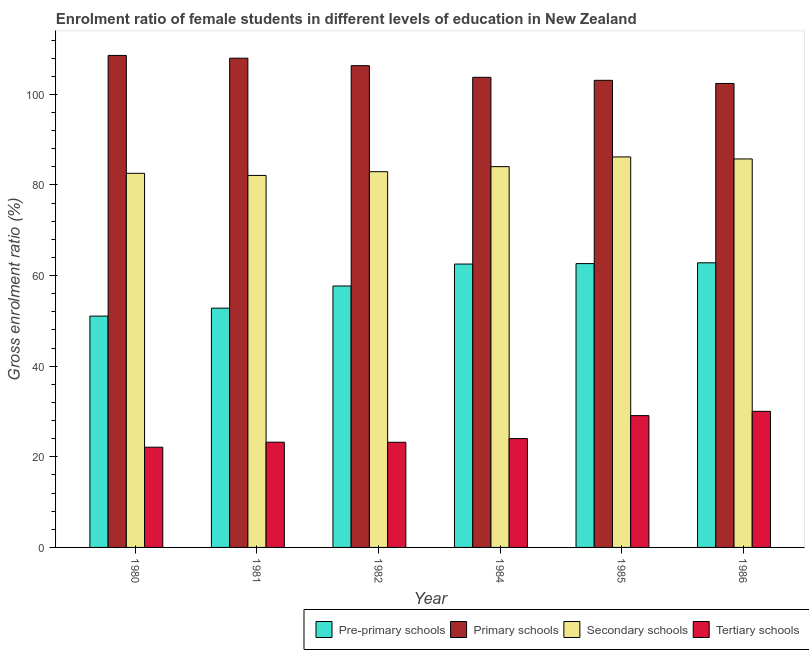How many different coloured bars are there?
Keep it short and to the point. 4. How many groups of bars are there?
Your answer should be compact. 6. Are the number of bars on each tick of the X-axis equal?
Give a very brief answer. Yes. How many bars are there on the 1st tick from the right?
Ensure brevity in your answer.  4. In how many cases, is the number of bars for a given year not equal to the number of legend labels?
Offer a very short reply. 0. What is the gross enrolment ratio(male) in pre-primary schools in 1980?
Your response must be concise. 51.06. Across all years, what is the maximum gross enrolment ratio(male) in primary schools?
Ensure brevity in your answer.  108.6. Across all years, what is the minimum gross enrolment ratio(male) in primary schools?
Your answer should be very brief. 102.41. In which year was the gross enrolment ratio(male) in primary schools maximum?
Your answer should be compact. 1980. In which year was the gross enrolment ratio(male) in secondary schools minimum?
Ensure brevity in your answer.  1981. What is the total gross enrolment ratio(male) in primary schools in the graph?
Provide a succinct answer. 632.19. What is the difference between the gross enrolment ratio(male) in secondary schools in 1981 and that in 1985?
Give a very brief answer. -4.08. What is the difference between the gross enrolment ratio(male) in primary schools in 1984 and the gross enrolment ratio(male) in tertiary schools in 1980?
Your answer should be very brief. -4.83. What is the average gross enrolment ratio(male) in secondary schools per year?
Provide a short and direct response. 83.93. What is the ratio of the gross enrolment ratio(male) in pre-primary schools in 1980 to that in 1985?
Give a very brief answer. 0.82. Is the gross enrolment ratio(male) in pre-primary schools in 1984 less than that in 1985?
Offer a very short reply. Yes. What is the difference between the highest and the second highest gross enrolment ratio(male) in tertiary schools?
Offer a very short reply. 0.94. What is the difference between the highest and the lowest gross enrolment ratio(male) in pre-primary schools?
Your answer should be very brief. 11.76. Is the sum of the gross enrolment ratio(male) in secondary schools in 1982 and 1986 greater than the maximum gross enrolment ratio(male) in primary schools across all years?
Make the answer very short. Yes. What does the 4th bar from the left in 1986 represents?
Ensure brevity in your answer.  Tertiary schools. What does the 1st bar from the right in 1980 represents?
Provide a succinct answer. Tertiary schools. Is it the case that in every year, the sum of the gross enrolment ratio(male) in pre-primary schools and gross enrolment ratio(male) in primary schools is greater than the gross enrolment ratio(male) in secondary schools?
Make the answer very short. Yes. How many bars are there?
Ensure brevity in your answer.  24. Does the graph contain any zero values?
Your answer should be very brief. No. Does the graph contain grids?
Offer a terse response. No. What is the title of the graph?
Your answer should be very brief. Enrolment ratio of female students in different levels of education in New Zealand. Does "Tertiary schools" appear as one of the legend labels in the graph?
Offer a very short reply. Yes. What is the label or title of the X-axis?
Your answer should be very brief. Year. What is the label or title of the Y-axis?
Make the answer very short. Gross enrolment ratio (%). What is the Gross enrolment ratio (%) in Pre-primary schools in 1980?
Your response must be concise. 51.06. What is the Gross enrolment ratio (%) in Primary schools in 1980?
Provide a short and direct response. 108.6. What is the Gross enrolment ratio (%) of Secondary schools in 1980?
Give a very brief answer. 82.58. What is the Gross enrolment ratio (%) in Tertiary schools in 1980?
Your answer should be very brief. 22.12. What is the Gross enrolment ratio (%) in Pre-primary schools in 1981?
Your answer should be compact. 52.81. What is the Gross enrolment ratio (%) in Primary schools in 1981?
Provide a short and direct response. 107.99. What is the Gross enrolment ratio (%) in Secondary schools in 1981?
Keep it short and to the point. 82.11. What is the Gross enrolment ratio (%) in Tertiary schools in 1981?
Ensure brevity in your answer.  23.23. What is the Gross enrolment ratio (%) of Pre-primary schools in 1982?
Offer a very short reply. 57.7. What is the Gross enrolment ratio (%) of Primary schools in 1982?
Provide a short and direct response. 106.33. What is the Gross enrolment ratio (%) of Secondary schools in 1982?
Ensure brevity in your answer.  82.93. What is the Gross enrolment ratio (%) in Tertiary schools in 1982?
Provide a succinct answer. 23.21. What is the Gross enrolment ratio (%) of Pre-primary schools in 1984?
Give a very brief answer. 62.55. What is the Gross enrolment ratio (%) of Primary schools in 1984?
Your answer should be very brief. 103.76. What is the Gross enrolment ratio (%) of Secondary schools in 1984?
Keep it short and to the point. 84.05. What is the Gross enrolment ratio (%) in Tertiary schools in 1984?
Offer a very short reply. 24.03. What is the Gross enrolment ratio (%) in Pre-primary schools in 1985?
Provide a succinct answer. 62.65. What is the Gross enrolment ratio (%) of Primary schools in 1985?
Provide a succinct answer. 103.1. What is the Gross enrolment ratio (%) of Secondary schools in 1985?
Offer a very short reply. 86.19. What is the Gross enrolment ratio (%) in Tertiary schools in 1985?
Give a very brief answer. 29.1. What is the Gross enrolment ratio (%) in Pre-primary schools in 1986?
Give a very brief answer. 62.82. What is the Gross enrolment ratio (%) of Primary schools in 1986?
Your response must be concise. 102.41. What is the Gross enrolment ratio (%) of Secondary schools in 1986?
Keep it short and to the point. 85.75. What is the Gross enrolment ratio (%) in Tertiary schools in 1986?
Your response must be concise. 30.04. Across all years, what is the maximum Gross enrolment ratio (%) of Pre-primary schools?
Your answer should be compact. 62.82. Across all years, what is the maximum Gross enrolment ratio (%) in Primary schools?
Give a very brief answer. 108.6. Across all years, what is the maximum Gross enrolment ratio (%) in Secondary schools?
Your response must be concise. 86.19. Across all years, what is the maximum Gross enrolment ratio (%) in Tertiary schools?
Your answer should be compact. 30.04. Across all years, what is the minimum Gross enrolment ratio (%) in Pre-primary schools?
Provide a succinct answer. 51.06. Across all years, what is the minimum Gross enrolment ratio (%) in Primary schools?
Ensure brevity in your answer.  102.41. Across all years, what is the minimum Gross enrolment ratio (%) in Secondary schools?
Provide a short and direct response. 82.11. Across all years, what is the minimum Gross enrolment ratio (%) in Tertiary schools?
Keep it short and to the point. 22.12. What is the total Gross enrolment ratio (%) of Pre-primary schools in the graph?
Provide a succinct answer. 349.59. What is the total Gross enrolment ratio (%) in Primary schools in the graph?
Your answer should be very brief. 632.19. What is the total Gross enrolment ratio (%) of Secondary schools in the graph?
Make the answer very short. 503.6. What is the total Gross enrolment ratio (%) in Tertiary schools in the graph?
Keep it short and to the point. 151.72. What is the difference between the Gross enrolment ratio (%) in Pre-primary schools in 1980 and that in 1981?
Offer a very short reply. -1.76. What is the difference between the Gross enrolment ratio (%) of Primary schools in 1980 and that in 1981?
Provide a succinct answer. 0.61. What is the difference between the Gross enrolment ratio (%) of Secondary schools in 1980 and that in 1981?
Your answer should be compact. 0.47. What is the difference between the Gross enrolment ratio (%) of Tertiary schools in 1980 and that in 1981?
Give a very brief answer. -1.11. What is the difference between the Gross enrolment ratio (%) of Pre-primary schools in 1980 and that in 1982?
Offer a very short reply. -6.65. What is the difference between the Gross enrolment ratio (%) in Primary schools in 1980 and that in 1982?
Keep it short and to the point. 2.26. What is the difference between the Gross enrolment ratio (%) in Secondary schools in 1980 and that in 1982?
Offer a terse response. -0.36. What is the difference between the Gross enrolment ratio (%) in Tertiary schools in 1980 and that in 1982?
Give a very brief answer. -1.09. What is the difference between the Gross enrolment ratio (%) in Pre-primary schools in 1980 and that in 1984?
Provide a short and direct response. -11.49. What is the difference between the Gross enrolment ratio (%) of Primary schools in 1980 and that in 1984?
Give a very brief answer. 4.83. What is the difference between the Gross enrolment ratio (%) in Secondary schools in 1980 and that in 1984?
Your response must be concise. -1.47. What is the difference between the Gross enrolment ratio (%) in Tertiary schools in 1980 and that in 1984?
Ensure brevity in your answer.  -1.91. What is the difference between the Gross enrolment ratio (%) in Pre-primary schools in 1980 and that in 1985?
Provide a short and direct response. -11.59. What is the difference between the Gross enrolment ratio (%) in Primary schools in 1980 and that in 1985?
Your answer should be compact. 5.5. What is the difference between the Gross enrolment ratio (%) in Secondary schools in 1980 and that in 1985?
Offer a terse response. -3.62. What is the difference between the Gross enrolment ratio (%) in Tertiary schools in 1980 and that in 1985?
Provide a short and direct response. -6.98. What is the difference between the Gross enrolment ratio (%) in Pre-primary schools in 1980 and that in 1986?
Provide a short and direct response. -11.76. What is the difference between the Gross enrolment ratio (%) in Primary schools in 1980 and that in 1986?
Keep it short and to the point. 6.19. What is the difference between the Gross enrolment ratio (%) of Secondary schools in 1980 and that in 1986?
Your answer should be very brief. -3.17. What is the difference between the Gross enrolment ratio (%) in Tertiary schools in 1980 and that in 1986?
Offer a terse response. -7.92. What is the difference between the Gross enrolment ratio (%) in Pre-primary schools in 1981 and that in 1982?
Your response must be concise. -4.89. What is the difference between the Gross enrolment ratio (%) in Primary schools in 1981 and that in 1982?
Give a very brief answer. 1.65. What is the difference between the Gross enrolment ratio (%) in Secondary schools in 1981 and that in 1982?
Offer a very short reply. -0.82. What is the difference between the Gross enrolment ratio (%) of Tertiary schools in 1981 and that in 1982?
Your answer should be very brief. 0.02. What is the difference between the Gross enrolment ratio (%) in Pre-primary schools in 1981 and that in 1984?
Your answer should be very brief. -9.73. What is the difference between the Gross enrolment ratio (%) in Primary schools in 1981 and that in 1984?
Keep it short and to the point. 4.22. What is the difference between the Gross enrolment ratio (%) in Secondary schools in 1981 and that in 1984?
Offer a terse response. -1.94. What is the difference between the Gross enrolment ratio (%) in Tertiary schools in 1981 and that in 1984?
Offer a terse response. -0.8. What is the difference between the Gross enrolment ratio (%) of Pre-primary schools in 1981 and that in 1985?
Provide a short and direct response. -9.83. What is the difference between the Gross enrolment ratio (%) of Primary schools in 1981 and that in 1985?
Provide a short and direct response. 4.89. What is the difference between the Gross enrolment ratio (%) of Secondary schools in 1981 and that in 1985?
Ensure brevity in your answer.  -4.08. What is the difference between the Gross enrolment ratio (%) of Tertiary schools in 1981 and that in 1985?
Keep it short and to the point. -5.87. What is the difference between the Gross enrolment ratio (%) in Pre-primary schools in 1981 and that in 1986?
Your answer should be compact. -10.01. What is the difference between the Gross enrolment ratio (%) in Primary schools in 1981 and that in 1986?
Give a very brief answer. 5.58. What is the difference between the Gross enrolment ratio (%) in Secondary schools in 1981 and that in 1986?
Your response must be concise. -3.64. What is the difference between the Gross enrolment ratio (%) of Tertiary schools in 1981 and that in 1986?
Your response must be concise. -6.81. What is the difference between the Gross enrolment ratio (%) in Pre-primary schools in 1982 and that in 1984?
Offer a very short reply. -4.84. What is the difference between the Gross enrolment ratio (%) of Primary schools in 1982 and that in 1984?
Provide a succinct answer. 2.57. What is the difference between the Gross enrolment ratio (%) in Secondary schools in 1982 and that in 1984?
Give a very brief answer. -1.11. What is the difference between the Gross enrolment ratio (%) of Tertiary schools in 1982 and that in 1984?
Your answer should be very brief. -0.82. What is the difference between the Gross enrolment ratio (%) of Pre-primary schools in 1982 and that in 1985?
Keep it short and to the point. -4.94. What is the difference between the Gross enrolment ratio (%) in Primary schools in 1982 and that in 1985?
Your answer should be compact. 3.23. What is the difference between the Gross enrolment ratio (%) in Secondary schools in 1982 and that in 1985?
Keep it short and to the point. -3.26. What is the difference between the Gross enrolment ratio (%) of Tertiary schools in 1982 and that in 1985?
Provide a short and direct response. -5.89. What is the difference between the Gross enrolment ratio (%) of Pre-primary schools in 1982 and that in 1986?
Your answer should be compact. -5.12. What is the difference between the Gross enrolment ratio (%) in Primary schools in 1982 and that in 1986?
Offer a very short reply. 3.92. What is the difference between the Gross enrolment ratio (%) in Secondary schools in 1982 and that in 1986?
Ensure brevity in your answer.  -2.81. What is the difference between the Gross enrolment ratio (%) of Tertiary schools in 1982 and that in 1986?
Your response must be concise. -6.83. What is the difference between the Gross enrolment ratio (%) of Pre-primary schools in 1984 and that in 1985?
Provide a succinct answer. -0.1. What is the difference between the Gross enrolment ratio (%) in Primary schools in 1984 and that in 1985?
Offer a terse response. 0.66. What is the difference between the Gross enrolment ratio (%) of Secondary schools in 1984 and that in 1985?
Provide a short and direct response. -2.14. What is the difference between the Gross enrolment ratio (%) of Tertiary schools in 1984 and that in 1985?
Provide a short and direct response. -5.07. What is the difference between the Gross enrolment ratio (%) of Pre-primary schools in 1984 and that in 1986?
Keep it short and to the point. -0.27. What is the difference between the Gross enrolment ratio (%) in Primary schools in 1984 and that in 1986?
Keep it short and to the point. 1.35. What is the difference between the Gross enrolment ratio (%) of Secondary schools in 1984 and that in 1986?
Your answer should be compact. -1.7. What is the difference between the Gross enrolment ratio (%) in Tertiary schools in 1984 and that in 1986?
Give a very brief answer. -6.01. What is the difference between the Gross enrolment ratio (%) in Pre-primary schools in 1985 and that in 1986?
Ensure brevity in your answer.  -0.17. What is the difference between the Gross enrolment ratio (%) of Primary schools in 1985 and that in 1986?
Give a very brief answer. 0.69. What is the difference between the Gross enrolment ratio (%) of Secondary schools in 1985 and that in 1986?
Provide a short and direct response. 0.44. What is the difference between the Gross enrolment ratio (%) of Tertiary schools in 1985 and that in 1986?
Keep it short and to the point. -0.94. What is the difference between the Gross enrolment ratio (%) in Pre-primary schools in 1980 and the Gross enrolment ratio (%) in Primary schools in 1981?
Make the answer very short. -56.93. What is the difference between the Gross enrolment ratio (%) of Pre-primary schools in 1980 and the Gross enrolment ratio (%) of Secondary schools in 1981?
Provide a short and direct response. -31.05. What is the difference between the Gross enrolment ratio (%) of Pre-primary schools in 1980 and the Gross enrolment ratio (%) of Tertiary schools in 1981?
Offer a terse response. 27.83. What is the difference between the Gross enrolment ratio (%) of Primary schools in 1980 and the Gross enrolment ratio (%) of Secondary schools in 1981?
Provide a succinct answer. 26.49. What is the difference between the Gross enrolment ratio (%) of Primary schools in 1980 and the Gross enrolment ratio (%) of Tertiary schools in 1981?
Make the answer very short. 85.37. What is the difference between the Gross enrolment ratio (%) in Secondary schools in 1980 and the Gross enrolment ratio (%) in Tertiary schools in 1981?
Offer a terse response. 59.35. What is the difference between the Gross enrolment ratio (%) of Pre-primary schools in 1980 and the Gross enrolment ratio (%) of Primary schools in 1982?
Offer a very short reply. -55.28. What is the difference between the Gross enrolment ratio (%) of Pre-primary schools in 1980 and the Gross enrolment ratio (%) of Secondary schools in 1982?
Your answer should be very brief. -31.88. What is the difference between the Gross enrolment ratio (%) in Pre-primary schools in 1980 and the Gross enrolment ratio (%) in Tertiary schools in 1982?
Keep it short and to the point. 27.85. What is the difference between the Gross enrolment ratio (%) of Primary schools in 1980 and the Gross enrolment ratio (%) of Secondary schools in 1982?
Your answer should be compact. 25.66. What is the difference between the Gross enrolment ratio (%) in Primary schools in 1980 and the Gross enrolment ratio (%) in Tertiary schools in 1982?
Your response must be concise. 85.39. What is the difference between the Gross enrolment ratio (%) in Secondary schools in 1980 and the Gross enrolment ratio (%) in Tertiary schools in 1982?
Make the answer very short. 59.36. What is the difference between the Gross enrolment ratio (%) of Pre-primary schools in 1980 and the Gross enrolment ratio (%) of Primary schools in 1984?
Keep it short and to the point. -52.7. What is the difference between the Gross enrolment ratio (%) of Pre-primary schools in 1980 and the Gross enrolment ratio (%) of Secondary schools in 1984?
Your answer should be very brief. -32.99. What is the difference between the Gross enrolment ratio (%) of Pre-primary schools in 1980 and the Gross enrolment ratio (%) of Tertiary schools in 1984?
Keep it short and to the point. 27.03. What is the difference between the Gross enrolment ratio (%) in Primary schools in 1980 and the Gross enrolment ratio (%) in Secondary schools in 1984?
Provide a short and direct response. 24.55. What is the difference between the Gross enrolment ratio (%) in Primary schools in 1980 and the Gross enrolment ratio (%) in Tertiary schools in 1984?
Ensure brevity in your answer.  84.57. What is the difference between the Gross enrolment ratio (%) of Secondary schools in 1980 and the Gross enrolment ratio (%) of Tertiary schools in 1984?
Keep it short and to the point. 58.55. What is the difference between the Gross enrolment ratio (%) of Pre-primary schools in 1980 and the Gross enrolment ratio (%) of Primary schools in 1985?
Your answer should be compact. -52.04. What is the difference between the Gross enrolment ratio (%) of Pre-primary schools in 1980 and the Gross enrolment ratio (%) of Secondary schools in 1985?
Offer a terse response. -35.13. What is the difference between the Gross enrolment ratio (%) in Pre-primary schools in 1980 and the Gross enrolment ratio (%) in Tertiary schools in 1985?
Ensure brevity in your answer.  21.96. What is the difference between the Gross enrolment ratio (%) of Primary schools in 1980 and the Gross enrolment ratio (%) of Secondary schools in 1985?
Your answer should be very brief. 22.41. What is the difference between the Gross enrolment ratio (%) in Primary schools in 1980 and the Gross enrolment ratio (%) in Tertiary schools in 1985?
Offer a terse response. 79.5. What is the difference between the Gross enrolment ratio (%) in Secondary schools in 1980 and the Gross enrolment ratio (%) in Tertiary schools in 1985?
Provide a succinct answer. 53.48. What is the difference between the Gross enrolment ratio (%) in Pre-primary schools in 1980 and the Gross enrolment ratio (%) in Primary schools in 1986?
Provide a short and direct response. -51.35. What is the difference between the Gross enrolment ratio (%) of Pre-primary schools in 1980 and the Gross enrolment ratio (%) of Secondary schools in 1986?
Your response must be concise. -34.69. What is the difference between the Gross enrolment ratio (%) of Pre-primary schools in 1980 and the Gross enrolment ratio (%) of Tertiary schools in 1986?
Keep it short and to the point. 21.02. What is the difference between the Gross enrolment ratio (%) in Primary schools in 1980 and the Gross enrolment ratio (%) in Secondary schools in 1986?
Give a very brief answer. 22.85. What is the difference between the Gross enrolment ratio (%) in Primary schools in 1980 and the Gross enrolment ratio (%) in Tertiary schools in 1986?
Ensure brevity in your answer.  78.56. What is the difference between the Gross enrolment ratio (%) of Secondary schools in 1980 and the Gross enrolment ratio (%) of Tertiary schools in 1986?
Your response must be concise. 52.54. What is the difference between the Gross enrolment ratio (%) of Pre-primary schools in 1981 and the Gross enrolment ratio (%) of Primary schools in 1982?
Keep it short and to the point. -53.52. What is the difference between the Gross enrolment ratio (%) in Pre-primary schools in 1981 and the Gross enrolment ratio (%) in Secondary schools in 1982?
Provide a short and direct response. -30.12. What is the difference between the Gross enrolment ratio (%) in Pre-primary schools in 1981 and the Gross enrolment ratio (%) in Tertiary schools in 1982?
Your answer should be compact. 29.6. What is the difference between the Gross enrolment ratio (%) of Primary schools in 1981 and the Gross enrolment ratio (%) of Secondary schools in 1982?
Your response must be concise. 25.05. What is the difference between the Gross enrolment ratio (%) in Primary schools in 1981 and the Gross enrolment ratio (%) in Tertiary schools in 1982?
Offer a very short reply. 84.78. What is the difference between the Gross enrolment ratio (%) in Secondary schools in 1981 and the Gross enrolment ratio (%) in Tertiary schools in 1982?
Your answer should be very brief. 58.9. What is the difference between the Gross enrolment ratio (%) of Pre-primary schools in 1981 and the Gross enrolment ratio (%) of Primary schools in 1984?
Provide a succinct answer. -50.95. What is the difference between the Gross enrolment ratio (%) of Pre-primary schools in 1981 and the Gross enrolment ratio (%) of Secondary schools in 1984?
Your answer should be compact. -31.23. What is the difference between the Gross enrolment ratio (%) of Pre-primary schools in 1981 and the Gross enrolment ratio (%) of Tertiary schools in 1984?
Your answer should be very brief. 28.79. What is the difference between the Gross enrolment ratio (%) of Primary schools in 1981 and the Gross enrolment ratio (%) of Secondary schools in 1984?
Give a very brief answer. 23.94. What is the difference between the Gross enrolment ratio (%) of Primary schools in 1981 and the Gross enrolment ratio (%) of Tertiary schools in 1984?
Your answer should be very brief. 83.96. What is the difference between the Gross enrolment ratio (%) of Secondary schools in 1981 and the Gross enrolment ratio (%) of Tertiary schools in 1984?
Offer a very short reply. 58.08. What is the difference between the Gross enrolment ratio (%) of Pre-primary schools in 1981 and the Gross enrolment ratio (%) of Primary schools in 1985?
Ensure brevity in your answer.  -50.29. What is the difference between the Gross enrolment ratio (%) of Pre-primary schools in 1981 and the Gross enrolment ratio (%) of Secondary schools in 1985?
Your answer should be very brief. -33.38. What is the difference between the Gross enrolment ratio (%) in Pre-primary schools in 1981 and the Gross enrolment ratio (%) in Tertiary schools in 1985?
Provide a short and direct response. 23.72. What is the difference between the Gross enrolment ratio (%) of Primary schools in 1981 and the Gross enrolment ratio (%) of Secondary schools in 1985?
Offer a terse response. 21.8. What is the difference between the Gross enrolment ratio (%) in Primary schools in 1981 and the Gross enrolment ratio (%) in Tertiary schools in 1985?
Provide a succinct answer. 78.89. What is the difference between the Gross enrolment ratio (%) in Secondary schools in 1981 and the Gross enrolment ratio (%) in Tertiary schools in 1985?
Offer a terse response. 53.01. What is the difference between the Gross enrolment ratio (%) in Pre-primary schools in 1981 and the Gross enrolment ratio (%) in Primary schools in 1986?
Offer a very short reply. -49.6. What is the difference between the Gross enrolment ratio (%) of Pre-primary schools in 1981 and the Gross enrolment ratio (%) of Secondary schools in 1986?
Your answer should be very brief. -32.93. What is the difference between the Gross enrolment ratio (%) in Pre-primary schools in 1981 and the Gross enrolment ratio (%) in Tertiary schools in 1986?
Your response must be concise. 22.78. What is the difference between the Gross enrolment ratio (%) in Primary schools in 1981 and the Gross enrolment ratio (%) in Secondary schools in 1986?
Offer a terse response. 22.24. What is the difference between the Gross enrolment ratio (%) in Primary schools in 1981 and the Gross enrolment ratio (%) in Tertiary schools in 1986?
Your answer should be very brief. 77.95. What is the difference between the Gross enrolment ratio (%) in Secondary schools in 1981 and the Gross enrolment ratio (%) in Tertiary schools in 1986?
Your answer should be very brief. 52.07. What is the difference between the Gross enrolment ratio (%) of Pre-primary schools in 1982 and the Gross enrolment ratio (%) of Primary schools in 1984?
Ensure brevity in your answer.  -46.06. What is the difference between the Gross enrolment ratio (%) of Pre-primary schools in 1982 and the Gross enrolment ratio (%) of Secondary schools in 1984?
Offer a very short reply. -26.34. What is the difference between the Gross enrolment ratio (%) in Pre-primary schools in 1982 and the Gross enrolment ratio (%) in Tertiary schools in 1984?
Provide a short and direct response. 33.68. What is the difference between the Gross enrolment ratio (%) of Primary schools in 1982 and the Gross enrolment ratio (%) of Secondary schools in 1984?
Your answer should be very brief. 22.29. What is the difference between the Gross enrolment ratio (%) in Primary schools in 1982 and the Gross enrolment ratio (%) in Tertiary schools in 1984?
Your answer should be compact. 82.31. What is the difference between the Gross enrolment ratio (%) of Secondary schools in 1982 and the Gross enrolment ratio (%) of Tertiary schools in 1984?
Give a very brief answer. 58.91. What is the difference between the Gross enrolment ratio (%) in Pre-primary schools in 1982 and the Gross enrolment ratio (%) in Primary schools in 1985?
Offer a very short reply. -45.4. What is the difference between the Gross enrolment ratio (%) of Pre-primary schools in 1982 and the Gross enrolment ratio (%) of Secondary schools in 1985?
Offer a terse response. -28.49. What is the difference between the Gross enrolment ratio (%) of Pre-primary schools in 1982 and the Gross enrolment ratio (%) of Tertiary schools in 1985?
Keep it short and to the point. 28.61. What is the difference between the Gross enrolment ratio (%) in Primary schools in 1982 and the Gross enrolment ratio (%) in Secondary schools in 1985?
Your response must be concise. 20.14. What is the difference between the Gross enrolment ratio (%) in Primary schools in 1982 and the Gross enrolment ratio (%) in Tertiary schools in 1985?
Make the answer very short. 77.24. What is the difference between the Gross enrolment ratio (%) in Secondary schools in 1982 and the Gross enrolment ratio (%) in Tertiary schools in 1985?
Provide a succinct answer. 53.84. What is the difference between the Gross enrolment ratio (%) in Pre-primary schools in 1982 and the Gross enrolment ratio (%) in Primary schools in 1986?
Your response must be concise. -44.71. What is the difference between the Gross enrolment ratio (%) in Pre-primary schools in 1982 and the Gross enrolment ratio (%) in Secondary schools in 1986?
Make the answer very short. -28.04. What is the difference between the Gross enrolment ratio (%) of Pre-primary schools in 1982 and the Gross enrolment ratio (%) of Tertiary schools in 1986?
Provide a succinct answer. 27.67. What is the difference between the Gross enrolment ratio (%) of Primary schools in 1982 and the Gross enrolment ratio (%) of Secondary schools in 1986?
Offer a very short reply. 20.59. What is the difference between the Gross enrolment ratio (%) in Primary schools in 1982 and the Gross enrolment ratio (%) in Tertiary schools in 1986?
Your answer should be compact. 76.3. What is the difference between the Gross enrolment ratio (%) in Secondary schools in 1982 and the Gross enrolment ratio (%) in Tertiary schools in 1986?
Give a very brief answer. 52.9. What is the difference between the Gross enrolment ratio (%) of Pre-primary schools in 1984 and the Gross enrolment ratio (%) of Primary schools in 1985?
Offer a very short reply. -40.55. What is the difference between the Gross enrolment ratio (%) of Pre-primary schools in 1984 and the Gross enrolment ratio (%) of Secondary schools in 1985?
Offer a terse response. -23.64. What is the difference between the Gross enrolment ratio (%) in Pre-primary schools in 1984 and the Gross enrolment ratio (%) in Tertiary schools in 1985?
Give a very brief answer. 33.45. What is the difference between the Gross enrolment ratio (%) in Primary schools in 1984 and the Gross enrolment ratio (%) in Secondary schools in 1985?
Ensure brevity in your answer.  17.57. What is the difference between the Gross enrolment ratio (%) in Primary schools in 1984 and the Gross enrolment ratio (%) in Tertiary schools in 1985?
Ensure brevity in your answer.  74.67. What is the difference between the Gross enrolment ratio (%) in Secondary schools in 1984 and the Gross enrolment ratio (%) in Tertiary schools in 1985?
Make the answer very short. 54.95. What is the difference between the Gross enrolment ratio (%) in Pre-primary schools in 1984 and the Gross enrolment ratio (%) in Primary schools in 1986?
Ensure brevity in your answer.  -39.86. What is the difference between the Gross enrolment ratio (%) of Pre-primary schools in 1984 and the Gross enrolment ratio (%) of Secondary schools in 1986?
Keep it short and to the point. -23.2. What is the difference between the Gross enrolment ratio (%) in Pre-primary schools in 1984 and the Gross enrolment ratio (%) in Tertiary schools in 1986?
Your answer should be compact. 32.51. What is the difference between the Gross enrolment ratio (%) of Primary schools in 1984 and the Gross enrolment ratio (%) of Secondary schools in 1986?
Give a very brief answer. 18.02. What is the difference between the Gross enrolment ratio (%) of Primary schools in 1984 and the Gross enrolment ratio (%) of Tertiary schools in 1986?
Provide a succinct answer. 73.72. What is the difference between the Gross enrolment ratio (%) in Secondary schools in 1984 and the Gross enrolment ratio (%) in Tertiary schools in 1986?
Your answer should be very brief. 54.01. What is the difference between the Gross enrolment ratio (%) in Pre-primary schools in 1985 and the Gross enrolment ratio (%) in Primary schools in 1986?
Your response must be concise. -39.76. What is the difference between the Gross enrolment ratio (%) in Pre-primary schools in 1985 and the Gross enrolment ratio (%) in Secondary schools in 1986?
Ensure brevity in your answer.  -23.1. What is the difference between the Gross enrolment ratio (%) of Pre-primary schools in 1985 and the Gross enrolment ratio (%) of Tertiary schools in 1986?
Your answer should be very brief. 32.61. What is the difference between the Gross enrolment ratio (%) in Primary schools in 1985 and the Gross enrolment ratio (%) in Secondary schools in 1986?
Provide a succinct answer. 17.35. What is the difference between the Gross enrolment ratio (%) of Primary schools in 1985 and the Gross enrolment ratio (%) of Tertiary schools in 1986?
Your response must be concise. 73.06. What is the difference between the Gross enrolment ratio (%) of Secondary schools in 1985 and the Gross enrolment ratio (%) of Tertiary schools in 1986?
Ensure brevity in your answer.  56.15. What is the average Gross enrolment ratio (%) of Pre-primary schools per year?
Give a very brief answer. 58.26. What is the average Gross enrolment ratio (%) in Primary schools per year?
Your answer should be very brief. 105.37. What is the average Gross enrolment ratio (%) in Secondary schools per year?
Offer a terse response. 83.93. What is the average Gross enrolment ratio (%) of Tertiary schools per year?
Your answer should be compact. 25.29. In the year 1980, what is the difference between the Gross enrolment ratio (%) in Pre-primary schools and Gross enrolment ratio (%) in Primary schools?
Your response must be concise. -57.54. In the year 1980, what is the difference between the Gross enrolment ratio (%) of Pre-primary schools and Gross enrolment ratio (%) of Secondary schools?
Keep it short and to the point. -31.52. In the year 1980, what is the difference between the Gross enrolment ratio (%) of Pre-primary schools and Gross enrolment ratio (%) of Tertiary schools?
Ensure brevity in your answer.  28.94. In the year 1980, what is the difference between the Gross enrolment ratio (%) in Primary schools and Gross enrolment ratio (%) in Secondary schools?
Your answer should be very brief. 26.02. In the year 1980, what is the difference between the Gross enrolment ratio (%) in Primary schools and Gross enrolment ratio (%) in Tertiary schools?
Ensure brevity in your answer.  86.48. In the year 1980, what is the difference between the Gross enrolment ratio (%) of Secondary schools and Gross enrolment ratio (%) of Tertiary schools?
Offer a terse response. 60.45. In the year 1981, what is the difference between the Gross enrolment ratio (%) of Pre-primary schools and Gross enrolment ratio (%) of Primary schools?
Your response must be concise. -55.17. In the year 1981, what is the difference between the Gross enrolment ratio (%) of Pre-primary schools and Gross enrolment ratio (%) of Secondary schools?
Your answer should be very brief. -29.3. In the year 1981, what is the difference between the Gross enrolment ratio (%) in Pre-primary schools and Gross enrolment ratio (%) in Tertiary schools?
Provide a succinct answer. 29.59. In the year 1981, what is the difference between the Gross enrolment ratio (%) in Primary schools and Gross enrolment ratio (%) in Secondary schools?
Make the answer very short. 25.88. In the year 1981, what is the difference between the Gross enrolment ratio (%) in Primary schools and Gross enrolment ratio (%) in Tertiary schools?
Keep it short and to the point. 84.76. In the year 1981, what is the difference between the Gross enrolment ratio (%) of Secondary schools and Gross enrolment ratio (%) of Tertiary schools?
Keep it short and to the point. 58.88. In the year 1982, what is the difference between the Gross enrolment ratio (%) of Pre-primary schools and Gross enrolment ratio (%) of Primary schools?
Your answer should be compact. -48.63. In the year 1982, what is the difference between the Gross enrolment ratio (%) in Pre-primary schools and Gross enrolment ratio (%) in Secondary schools?
Provide a succinct answer. -25.23. In the year 1982, what is the difference between the Gross enrolment ratio (%) in Pre-primary schools and Gross enrolment ratio (%) in Tertiary schools?
Give a very brief answer. 34.49. In the year 1982, what is the difference between the Gross enrolment ratio (%) in Primary schools and Gross enrolment ratio (%) in Secondary schools?
Provide a succinct answer. 23.4. In the year 1982, what is the difference between the Gross enrolment ratio (%) of Primary schools and Gross enrolment ratio (%) of Tertiary schools?
Offer a terse response. 83.12. In the year 1982, what is the difference between the Gross enrolment ratio (%) of Secondary schools and Gross enrolment ratio (%) of Tertiary schools?
Keep it short and to the point. 59.72. In the year 1984, what is the difference between the Gross enrolment ratio (%) of Pre-primary schools and Gross enrolment ratio (%) of Primary schools?
Offer a terse response. -41.21. In the year 1984, what is the difference between the Gross enrolment ratio (%) of Pre-primary schools and Gross enrolment ratio (%) of Secondary schools?
Keep it short and to the point. -21.5. In the year 1984, what is the difference between the Gross enrolment ratio (%) of Pre-primary schools and Gross enrolment ratio (%) of Tertiary schools?
Offer a terse response. 38.52. In the year 1984, what is the difference between the Gross enrolment ratio (%) in Primary schools and Gross enrolment ratio (%) in Secondary schools?
Make the answer very short. 19.72. In the year 1984, what is the difference between the Gross enrolment ratio (%) of Primary schools and Gross enrolment ratio (%) of Tertiary schools?
Ensure brevity in your answer.  79.74. In the year 1984, what is the difference between the Gross enrolment ratio (%) of Secondary schools and Gross enrolment ratio (%) of Tertiary schools?
Keep it short and to the point. 60.02. In the year 1985, what is the difference between the Gross enrolment ratio (%) of Pre-primary schools and Gross enrolment ratio (%) of Primary schools?
Keep it short and to the point. -40.45. In the year 1985, what is the difference between the Gross enrolment ratio (%) of Pre-primary schools and Gross enrolment ratio (%) of Secondary schools?
Ensure brevity in your answer.  -23.54. In the year 1985, what is the difference between the Gross enrolment ratio (%) in Pre-primary schools and Gross enrolment ratio (%) in Tertiary schools?
Offer a terse response. 33.55. In the year 1985, what is the difference between the Gross enrolment ratio (%) in Primary schools and Gross enrolment ratio (%) in Secondary schools?
Provide a succinct answer. 16.91. In the year 1985, what is the difference between the Gross enrolment ratio (%) in Primary schools and Gross enrolment ratio (%) in Tertiary schools?
Your response must be concise. 74. In the year 1985, what is the difference between the Gross enrolment ratio (%) in Secondary schools and Gross enrolment ratio (%) in Tertiary schools?
Provide a succinct answer. 57.09. In the year 1986, what is the difference between the Gross enrolment ratio (%) of Pre-primary schools and Gross enrolment ratio (%) of Primary schools?
Make the answer very short. -39.59. In the year 1986, what is the difference between the Gross enrolment ratio (%) of Pre-primary schools and Gross enrolment ratio (%) of Secondary schools?
Provide a succinct answer. -22.93. In the year 1986, what is the difference between the Gross enrolment ratio (%) in Pre-primary schools and Gross enrolment ratio (%) in Tertiary schools?
Your response must be concise. 32.78. In the year 1986, what is the difference between the Gross enrolment ratio (%) of Primary schools and Gross enrolment ratio (%) of Secondary schools?
Offer a very short reply. 16.66. In the year 1986, what is the difference between the Gross enrolment ratio (%) in Primary schools and Gross enrolment ratio (%) in Tertiary schools?
Offer a very short reply. 72.37. In the year 1986, what is the difference between the Gross enrolment ratio (%) of Secondary schools and Gross enrolment ratio (%) of Tertiary schools?
Ensure brevity in your answer.  55.71. What is the ratio of the Gross enrolment ratio (%) in Pre-primary schools in 1980 to that in 1981?
Give a very brief answer. 0.97. What is the ratio of the Gross enrolment ratio (%) of Primary schools in 1980 to that in 1981?
Your response must be concise. 1.01. What is the ratio of the Gross enrolment ratio (%) of Tertiary schools in 1980 to that in 1981?
Ensure brevity in your answer.  0.95. What is the ratio of the Gross enrolment ratio (%) in Pre-primary schools in 1980 to that in 1982?
Offer a terse response. 0.88. What is the ratio of the Gross enrolment ratio (%) in Primary schools in 1980 to that in 1982?
Offer a very short reply. 1.02. What is the ratio of the Gross enrolment ratio (%) of Tertiary schools in 1980 to that in 1982?
Provide a succinct answer. 0.95. What is the ratio of the Gross enrolment ratio (%) in Pre-primary schools in 1980 to that in 1984?
Your answer should be very brief. 0.82. What is the ratio of the Gross enrolment ratio (%) in Primary schools in 1980 to that in 1984?
Your response must be concise. 1.05. What is the ratio of the Gross enrolment ratio (%) of Secondary schools in 1980 to that in 1984?
Provide a succinct answer. 0.98. What is the ratio of the Gross enrolment ratio (%) of Tertiary schools in 1980 to that in 1984?
Your answer should be very brief. 0.92. What is the ratio of the Gross enrolment ratio (%) of Pre-primary schools in 1980 to that in 1985?
Your response must be concise. 0.81. What is the ratio of the Gross enrolment ratio (%) of Primary schools in 1980 to that in 1985?
Provide a succinct answer. 1.05. What is the ratio of the Gross enrolment ratio (%) in Secondary schools in 1980 to that in 1985?
Give a very brief answer. 0.96. What is the ratio of the Gross enrolment ratio (%) in Tertiary schools in 1980 to that in 1985?
Ensure brevity in your answer.  0.76. What is the ratio of the Gross enrolment ratio (%) in Pre-primary schools in 1980 to that in 1986?
Offer a very short reply. 0.81. What is the ratio of the Gross enrolment ratio (%) in Primary schools in 1980 to that in 1986?
Provide a succinct answer. 1.06. What is the ratio of the Gross enrolment ratio (%) of Tertiary schools in 1980 to that in 1986?
Provide a short and direct response. 0.74. What is the ratio of the Gross enrolment ratio (%) in Pre-primary schools in 1981 to that in 1982?
Your answer should be very brief. 0.92. What is the ratio of the Gross enrolment ratio (%) in Primary schools in 1981 to that in 1982?
Give a very brief answer. 1.02. What is the ratio of the Gross enrolment ratio (%) in Pre-primary schools in 1981 to that in 1984?
Provide a succinct answer. 0.84. What is the ratio of the Gross enrolment ratio (%) in Primary schools in 1981 to that in 1984?
Offer a terse response. 1.04. What is the ratio of the Gross enrolment ratio (%) in Secondary schools in 1981 to that in 1984?
Your answer should be very brief. 0.98. What is the ratio of the Gross enrolment ratio (%) in Tertiary schools in 1981 to that in 1984?
Offer a very short reply. 0.97. What is the ratio of the Gross enrolment ratio (%) in Pre-primary schools in 1981 to that in 1985?
Your answer should be compact. 0.84. What is the ratio of the Gross enrolment ratio (%) in Primary schools in 1981 to that in 1985?
Offer a very short reply. 1.05. What is the ratio of the Gross enrolment ratio (%) in Secondary schools in 1981 to that in 1985?
Provide a succinct answer. 0.95. What is the ratio of the Gross enrolment ratio (%) in Tertiary schools in 1981 to that in 1985?
Offer a terse response. 0.8. What is the ratio of the Gross enrolment ratio (%) of Pre-primary schools in 1981 to that in 1986?
Your answer should be very brief. 0.84. What is the ratio of the Gross enrolment ratio (%) in Primary schools in 1981 to that in 1986?
Your response must be concise. 1.05. What is the ratio of the Gross enrolment ratio (%) in Secondary schools in 1981 to that in 1986?
Provide a short and direct response. 0.96. What is the ratio of the Gross enrolment ratio (%) of Tertiary schools in 1981 to that in 1986?
Your response must be concise. 0.77. What is the ratio of the Gross enrolment ratio (%) of Pre-primary schools in 1982 to that in 1984?
Offer a terse response. 0.92. What is the ratio of the Gross enrolment ratio (%) of Primary schools in 1982 to that in 1984?
Your response must be concise. 1.02. What is the ratio of the Gross enrolment ratio (%) of Secondary schools in 1982 to that in 1984?
Give a very brief answer. 0.99. What is the ratio of the Gross enrolment ratio (%) of Tertiary schools in 1982 to that in 1984?
Provide a short and direct response. 0.97. What is the ratio of the Gross enrolment ratio (%) in Pre-primary schools in 1982 to that in 1985?
Provide a short and direct response. 0.92. What is the ratio of the Gross enrolment ratio (%) of Primary schools in 1982 to that in 1985?
Ensure brevity in your answer.  1.03. What is the ratio of the Gross enrolment ratio (%) of Secondary schools in 1982 to that in 1985?
Offer a terse response. 0.96. What is the ratio of the Gross enrolment ratio (%) of Tertiary schools in 1982 to that in 1985?
Make the answer very short. 0.8. What is the ratio of the Gross enrolment ratio (%) in Pre-primary schools in 1982 to that in 1986?
Your answer should be very brief. 0.92. What is the ratio of the Gross enrolment ratio (%) in Primary schools in 1982 to that in 1986?
Your answer should be compact. 1.04. What is the ratio of the Gross enrolment ratio (%) in Secondary schools in 1982 to that in 1986?
Your answer should be very brief. 0.97. What is the ratio of the Gross enrolment ratio (%) of Tertiary schools in 1982 to that in 1986?
Make the answer very short. 0.77. What is the ratio of the Gross enrolment ratio (%) in Primary schools in 1984 to that in 1985?
Provide a succinct answer. 1.01. What is the ratio of the Gross enrolment ratio (%) of Secondary schools in 1984 to that in 1985?
Offer a terse response. 0.98. What is the ratio of the Gross enrolment ratio (%) of Tertiary schools in 1984 to that in 1985?
Provide a succinct answer. 0.83. What is the ratio of the Gross enrolment ratio (%) of Pre-primary schools in 1984 to that in 1986?
Your answer should be compact. 1. What is the ratio of the Gross enrolment ratio (%) of Primary schools in 1984 to that in 1986?
Offer a very short reply. 1.01. What is the ratio of the Gross enrolment ratio (%) of Secondary schools in 1984 to that in 1986?
Provide a succinct answer. 0.98. What is the ratio of the Gross enrolment ratio (%) of Tertiary schools in 1984 to that in 1986?
Offer a terse response. 0.8. What is the ratio of the Gross enrolment ratio (%) of Secondary schools in 1985 to that in 1986?
Your answer should be compact. 1.01. What is the ratio of the Gross enrolment ratio (%) of Tertiary schools in 1985 to that in 1986?
Keep it short and to the point. 0.97. What is the difference between the highest and the second highest Gross enrolment ratio (%) of Pre-primary schools?
Your answer should be compact. 0.17. What is the difference between the highest and the second highest Gross enrolment ratio (%) in Primary schools?
Your answer should be very brief. 0.61. What is the difference between the highest and the second highest Gross enrolment ratio (%) of Secondary schools?
Give a very brief answer. 0.44. What is the difference between the highest and the second highest Gross enrolment ratio (%) in Tertiary schools?
Your answer should be very brief. 0.94. What is the difference between the highest and the lowest Gross enrolment ratio (%) of Pre-primary schools?
Your answer should be compact. 11.76. What is the difference between the highest and the lowest Gross enrolment ratio (%) in Primary schools?
Provide a succinct answer. 6.19. What is the difference between the highest and the lowest Gross enrolment ratio (%) of Secondary schools?
Your answer should be very brief. 4.08. What is the difference between the highest and the lowest Gross enrolment ratio (%) of Tertiary schools?
Give a very brief answer. 7.92. 